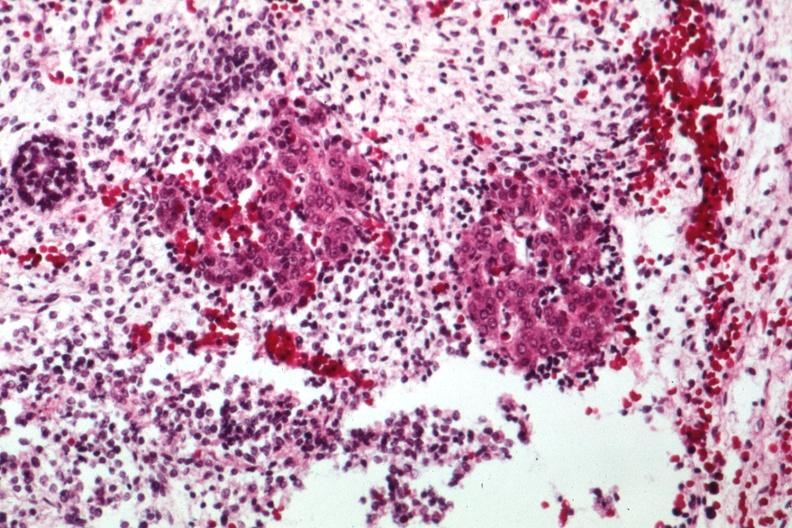what does this image show?
Answer the question using a single word or phrase. Acinar tissue looking like pancreas with primitive stroma 